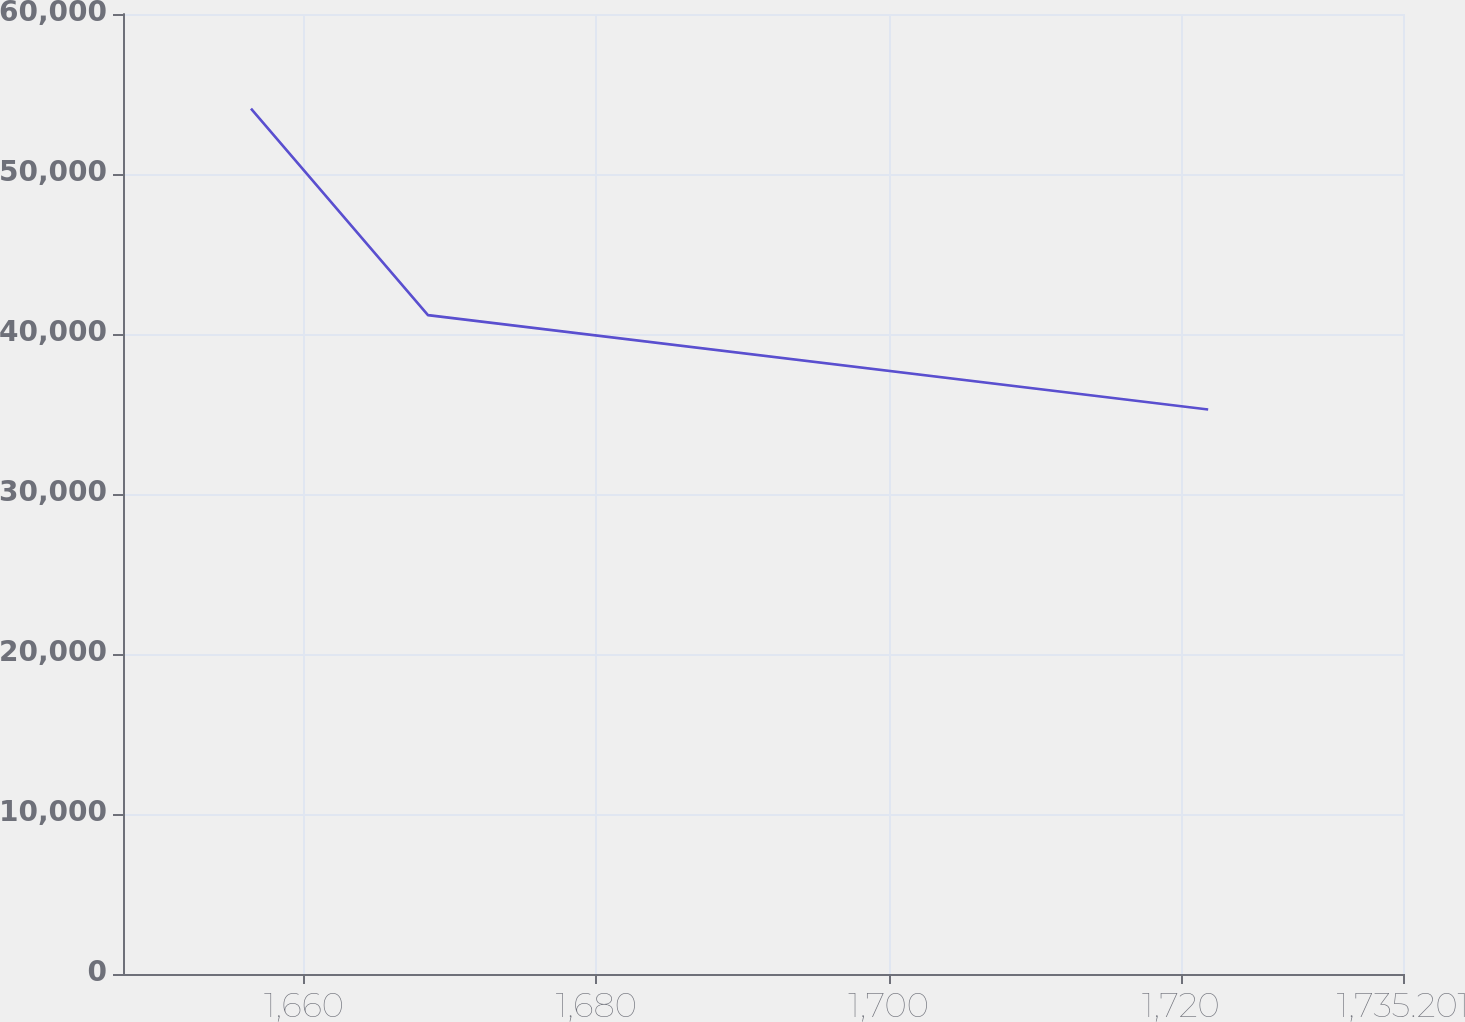<chart> <loc_0><loc_0><loc_500><loc_500><line_chart><ecel><fcel>Amount<nl><fcel>1656.37<fcel>54081.3<nl><fcel>1668.48<fcel>41181.4<nl><fcel>1721.87<fcel>35285.2<nl><fcel>1735.49<fcel>32355.8<nl><fcel>1743.96<fcel>28467.4<nl></chart> 